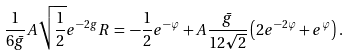<formula> <loc_0><loc_0><loc_500><loc_500>\frac { 1 } { 6 \bar { g } } A \sqrt { \frac { 1 } { 2 } } e ^ { - 2 g } R \, = \, - \frac { 1 } { 2 } e ^ { - \varphi } + A \frac { \bar { g } } { 1 2 \sqrt { 2 } } \left ( 2 e ^ { - 2 \varphi } + e ^ { \varphi } \right ) .</formula> 